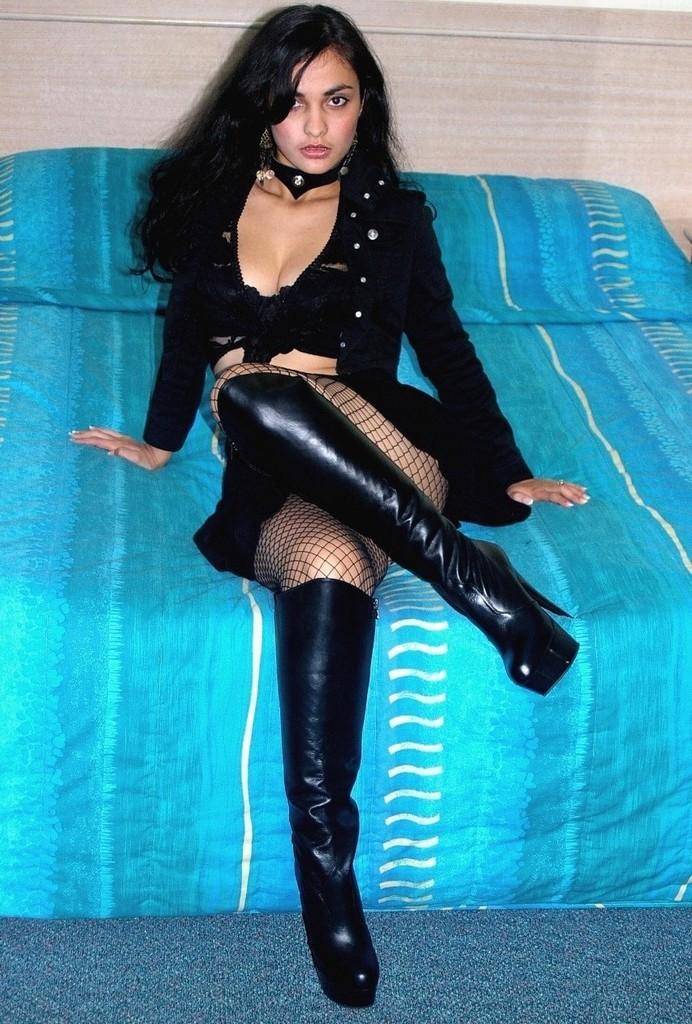Could you give a brief overview of what you see in this image? There is a lady wearing boots is sitting on a bed. In the back there is a wall. 